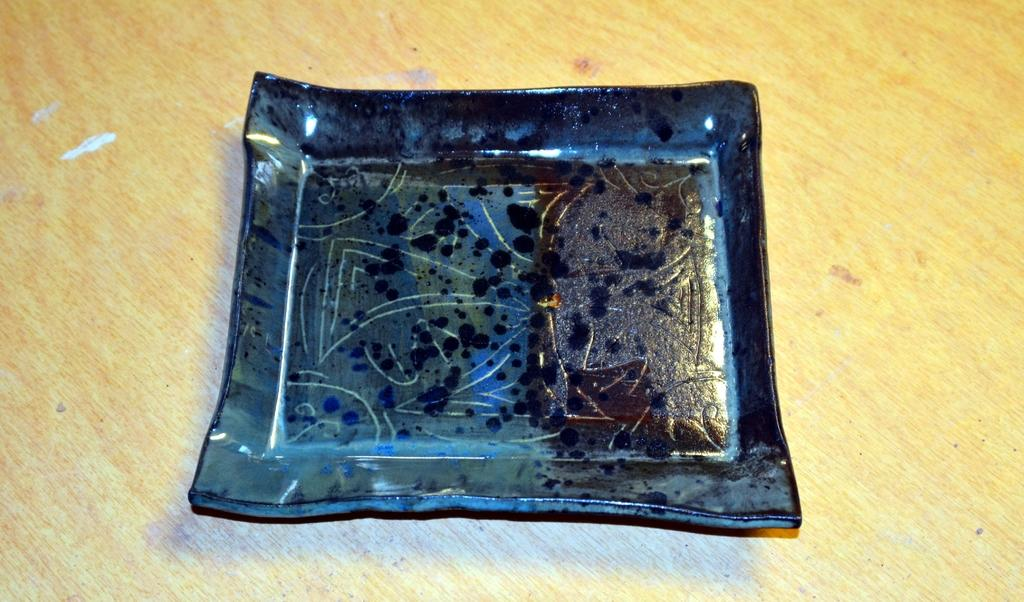What object is visible on the table in the image? There is a plate in the image. Where is the plate located in the image? The plate is placed on a table. What type of boot is depicted on the plate in the image? There is no boot present on the plate in the image. What nation is represented by the plate in the image? The image does not provide information about the nation represented by the plate. Is there a chess game being played on the plate in the image? There is no chess game present on the plate in the image. 